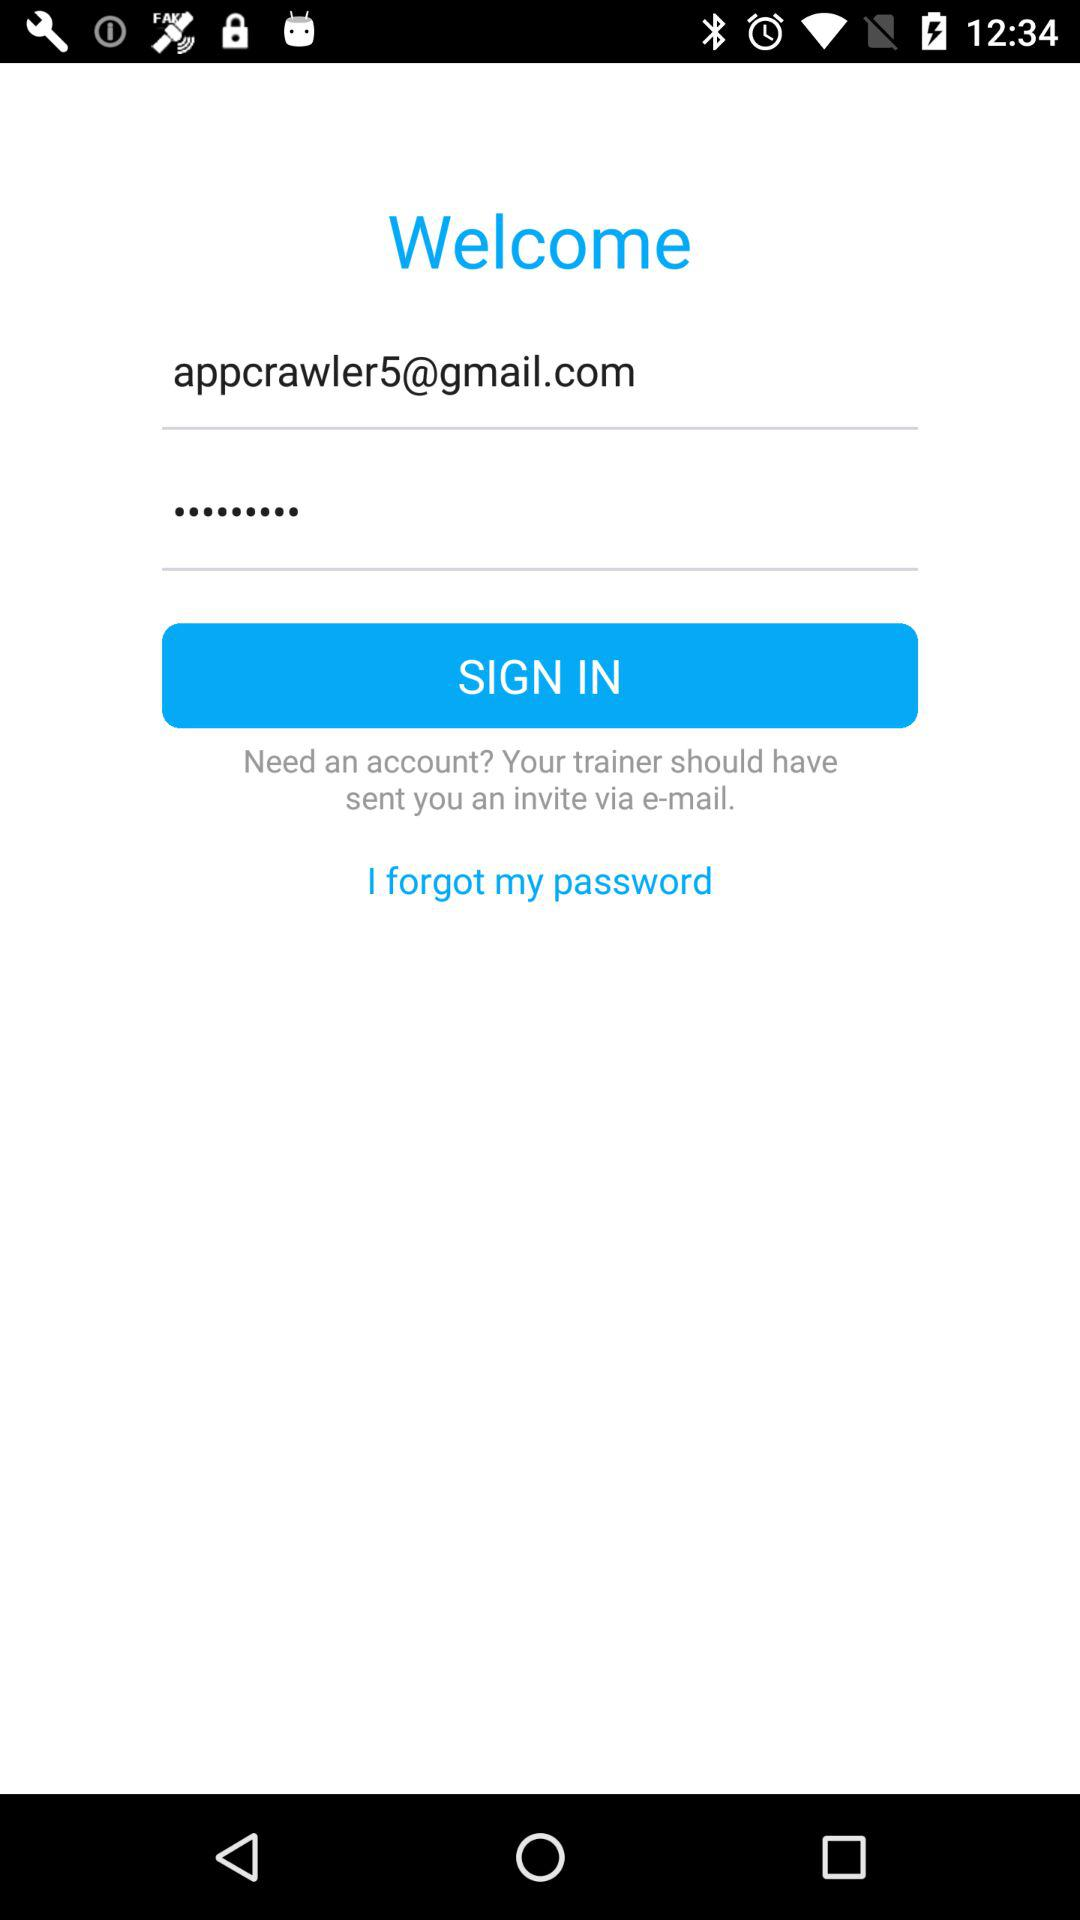What is the Gmail account address? The Gmail account address is appcrawler5@gmail.com. 